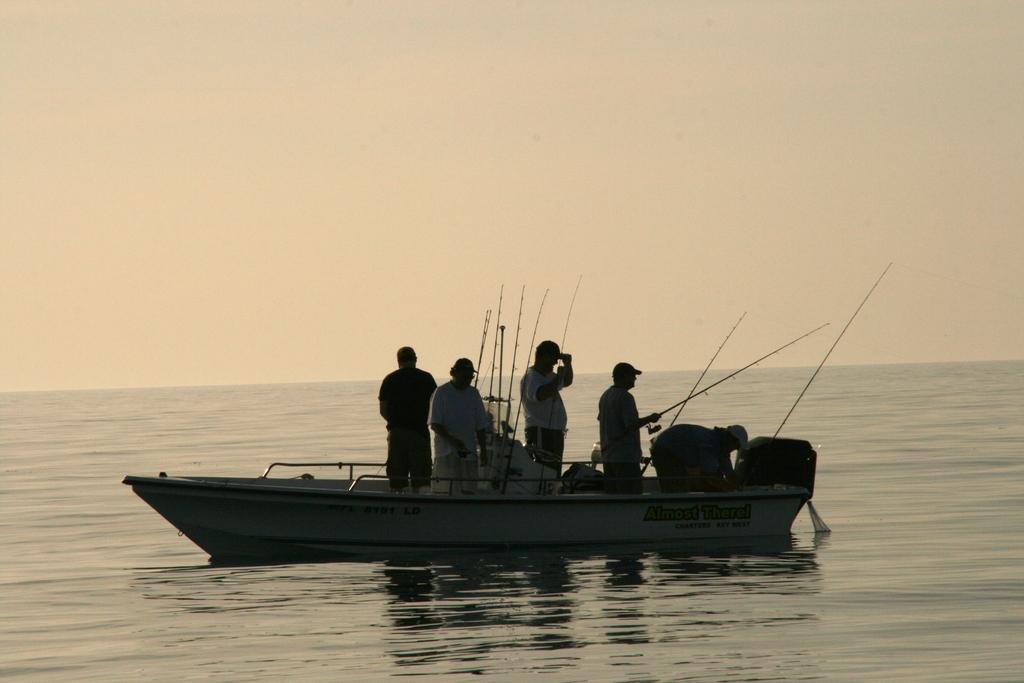What is the main subject in the center of the image? There is a boat in the center of the image. What are the people in the boat doing? The people are standing in the boat and holding fishing rods. What can be seen in the background of the image? There is sky and water visible in the background of the image. What is the condition of the sky in the image? The sky has clouds in it. What type of stamp can be seen on the boat in the image? There is no stamp present on the boat in the image. What is the purpose of the protest happening on the boat in the image? There is no protest happening on the boat in the image. 